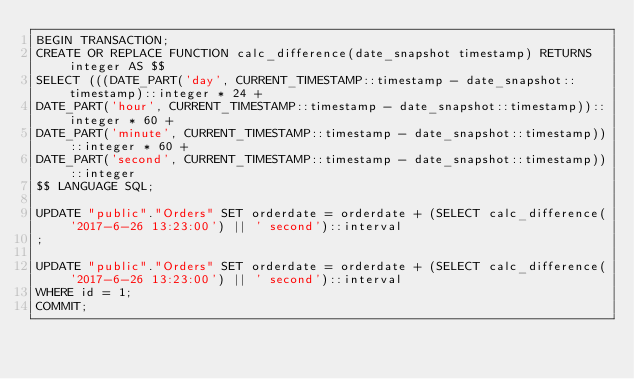<code> <loc_0><loc_0><loc_500><loc_500><_SQL_>BEGIN TRANSACTION;
CREATE OR REPLACE FUNCTION calc_difference(date_snapshot timestamp) RETURNS integer AS $$ 
SELECT (((DATE_PART('day', CURRENT_TIMESTAMP::timestamp - date_snapshot::timestamp)::integer * 24 + 
DATE_PART('hour', CURRENT_TIMESTAMP::timestamp - date_snapshot::timestamp))::integer * 60 + 
DATE_PART('minute', CURRENT_TIMESTAMP::timestamp - date_snapshot::timestamp))::integer * 60 + 
DATE_PART('second', CURRENT_TIMESTAMP::timestamp - date_snapshot::timestamp))::integer 
$$ LANGUAGE SQL;

UPDATE "public"."Orders" SET orderdate = orderdate + (SELECT calc_difference('2017-6-26 13:23:00') || ' second')::interval
;

UPDATE "public"."Orders" SET orderdate = orderdate + (SELECT calc_difference('2017-6-26 13:23:00') || ' second')::interval
WHERE id = 1;
COMMIT;</code> 